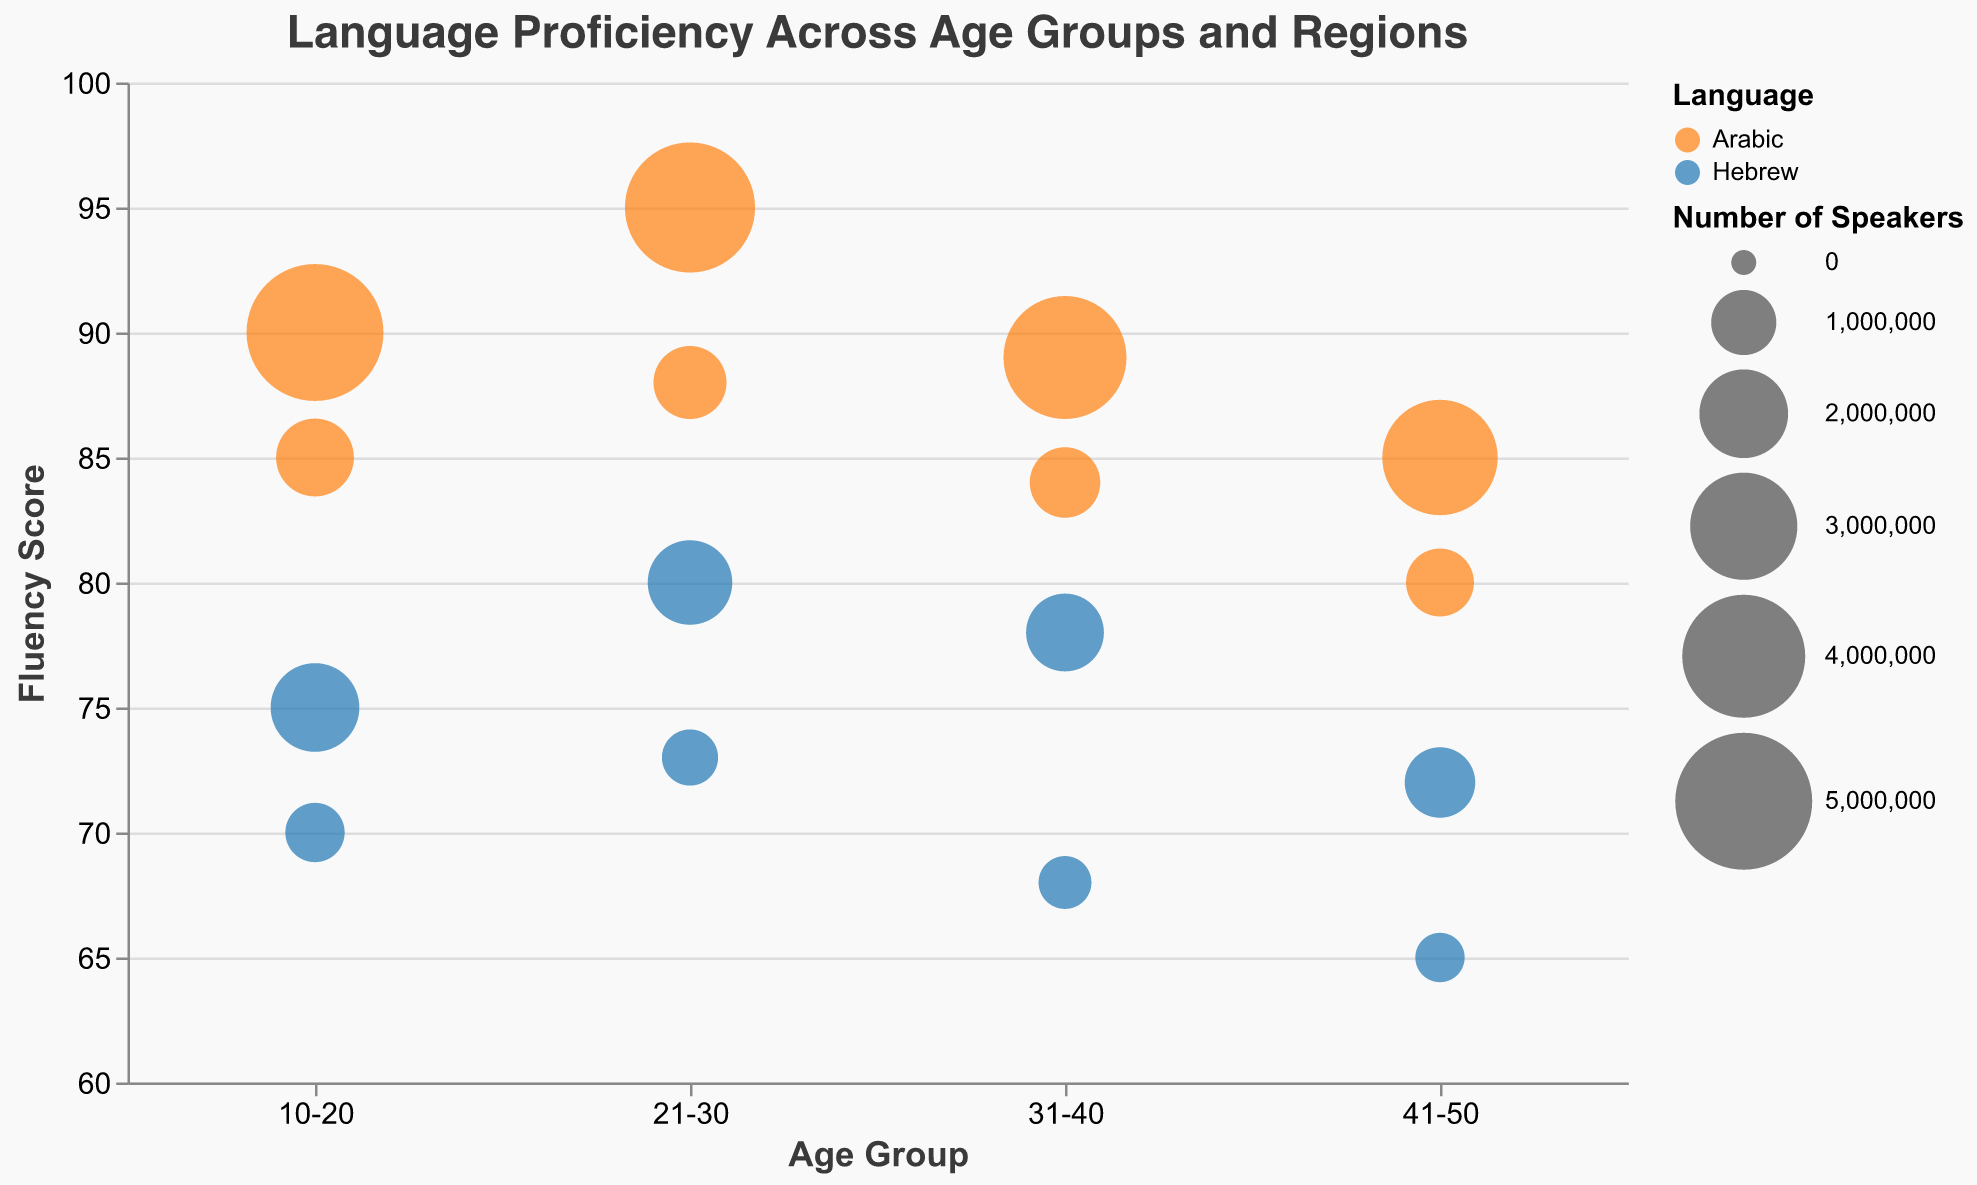What is the title of the figure? The title of the figure is displayed at the top of the figure. The text reads "Language Proficiency Across Age Groups and Regions".
Answer: Language Proficiency Across Age Groups and Regions Which language has the highest fluency score in the 21-30 age group in the Middle East? In the 21-30 age group in the Middle East, two languages are indicated: Arabic and Hebrew. The fluency scores are 95 for Arabic and 80 for Hebrew. Arabic has the highest fluency score.
Answer: Arabic What is the size range for the bubbles in the plot? The size range for the bubbles is indicated by the size legend, which shows a range from 100 to 3000.
Answer: 100 to 3000 Which region uses circles and which uses squares for the bubbles? The shape legend indicates that circles represent the Middle East and squares represent Europe.
Answer: Middle East: circles, Europe: squares Are there any age groups where the fluency score of Arabic in the Middle East is less than 90? Checking through the figure for age groups in the Middle East where the fluency score of Arabic is shown, we see that the scores are 90, 95, 89, and 85 for the respective age groups. Scores of 89 and 85 are less than 90.
Answer: Yes Which age group has the fewest number of Hebrew speakers in Europe? The figure shows the number of Hebrew speakers for different age groups in Europe. The age groups and respective numbers of speakers are: 10-20 (800,000), 21-30 (700,000), 31-40 (600,000), and 41-50 (500,000). The 41-50 age group has the fewest.
Answer: 41-50 How does the fluency score of Hebrew in Europe change across different age groups? The age groups and their corresponding fluency scores for Hebrew in Europe are: 10-20 (70), 21-30 (73), 31-40 (68), and 41-50 (65). From 10-20 to 21-30, the fluency score increases from 70 to 73, then decreases to 68 in 31-40, and further decreases to 65 in 41-50.
Answer: Initially increases then decreases What is the total number of Arabic speakers across all age groups in the Middle East? The number of Arabic speakers across different age groups in the Middle East are: 10-20 (5,000,000), 21-30 (4,500,000), 31-40 (4,000,000), and 41-50 (3,500,000). Adding these values gives 5,000,000 + 4,500,000 + 4,000,000 + 3,500,000 = 17,000,000.
Answer: 17,000,000 In which age group in Europe is the gap between the fluency scores of Hebrew and Arabic the largest? In Europe, the fluency scores for different age groups are: 10-20 (Arabic: 85, Hebrew: 70), 21-30 (Arabic: 88, Hebrew: 73), 31-40 (Arabic: 84, Hebrew: 68), and 41-50 (Arabic: 80, Hebrew: 65). Calculating the differences: 10-20 (15), 21-30 (15), 31-40 (16), and 41-50 (15). The largest gap is in the 31-40 age group with a difference of 16.
Answer: 31-40 